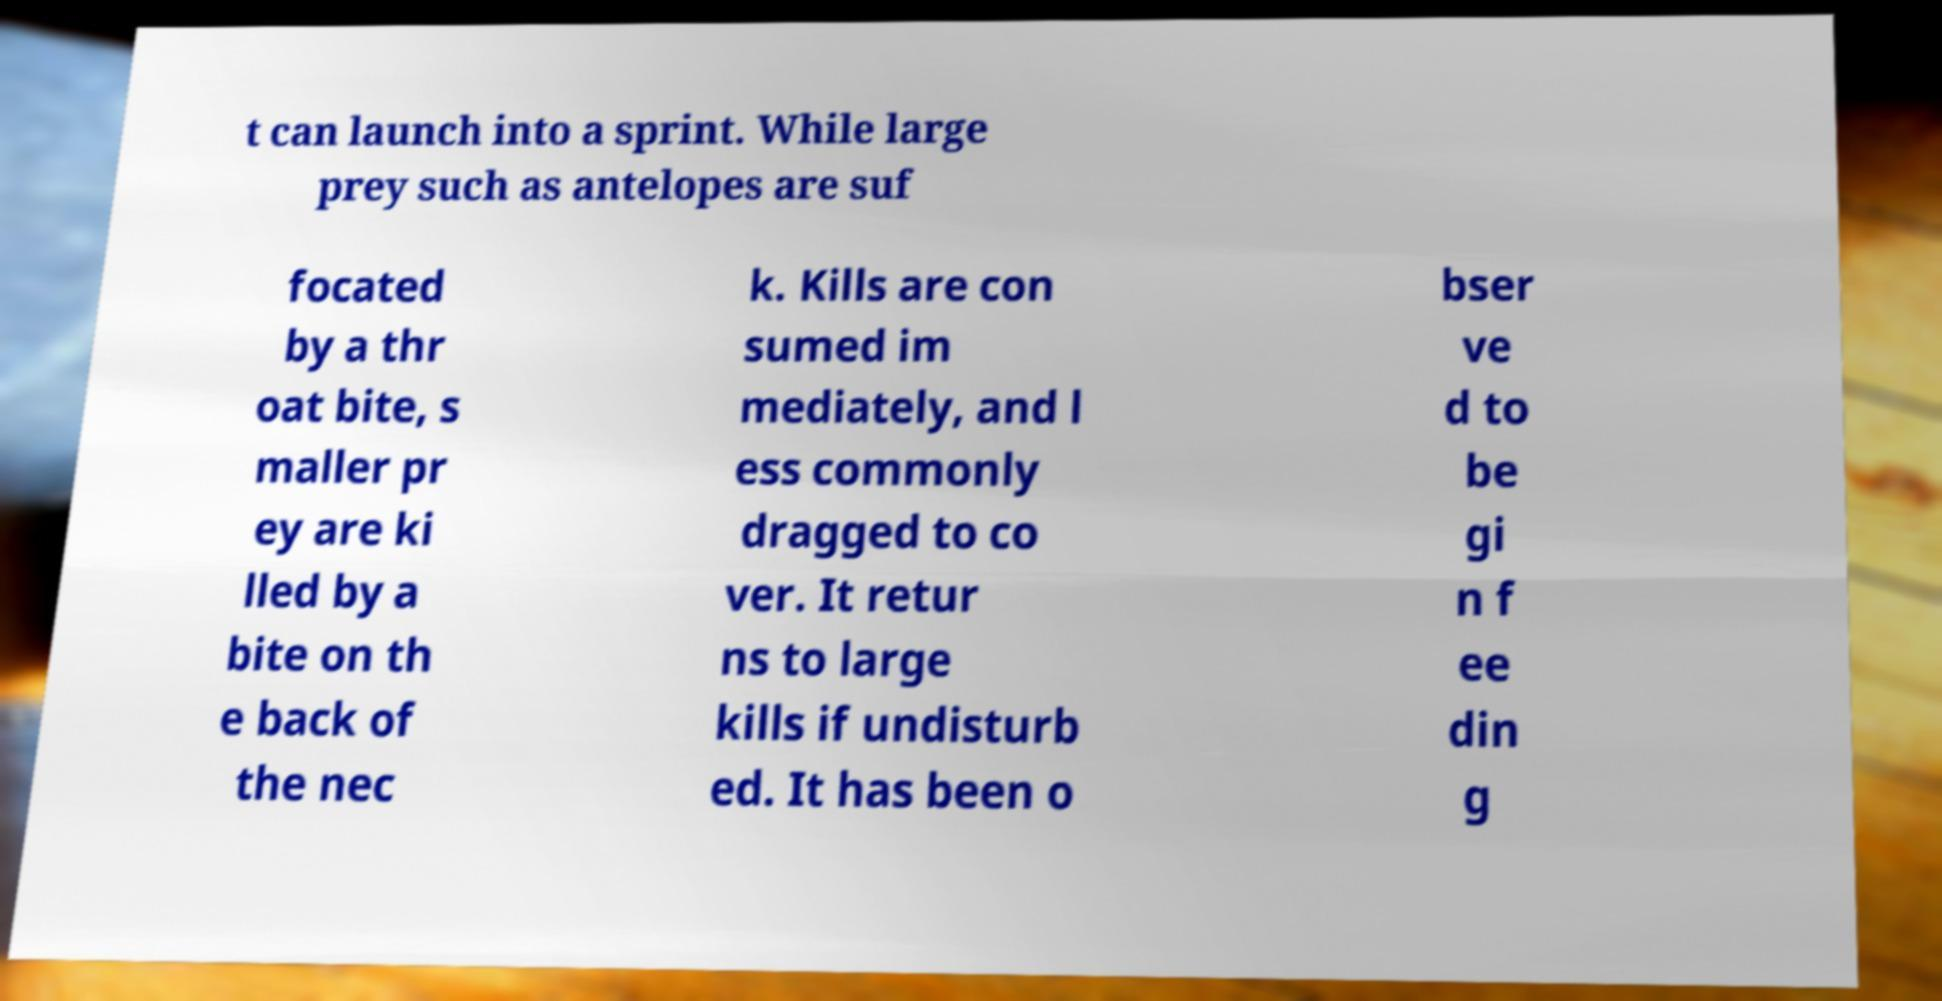Could you extract and type out the text from this image? t can launch into a sprint. While large prey such as antelopes are suf focated by a thr oat bite, s maller pr ey are ki lled by a bite on th e back of the nec k. Kills are con sumed im mediately, and l ess commonly dragged to co ver. It retur ns to large kills if undisturb ed. It has been o bser ve d to be gi n f ee din g 